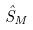Convert formula to latex. <formula><loc_0><loc_0><loc_500><loc_500>\hat { S } _ { M }</formula> 